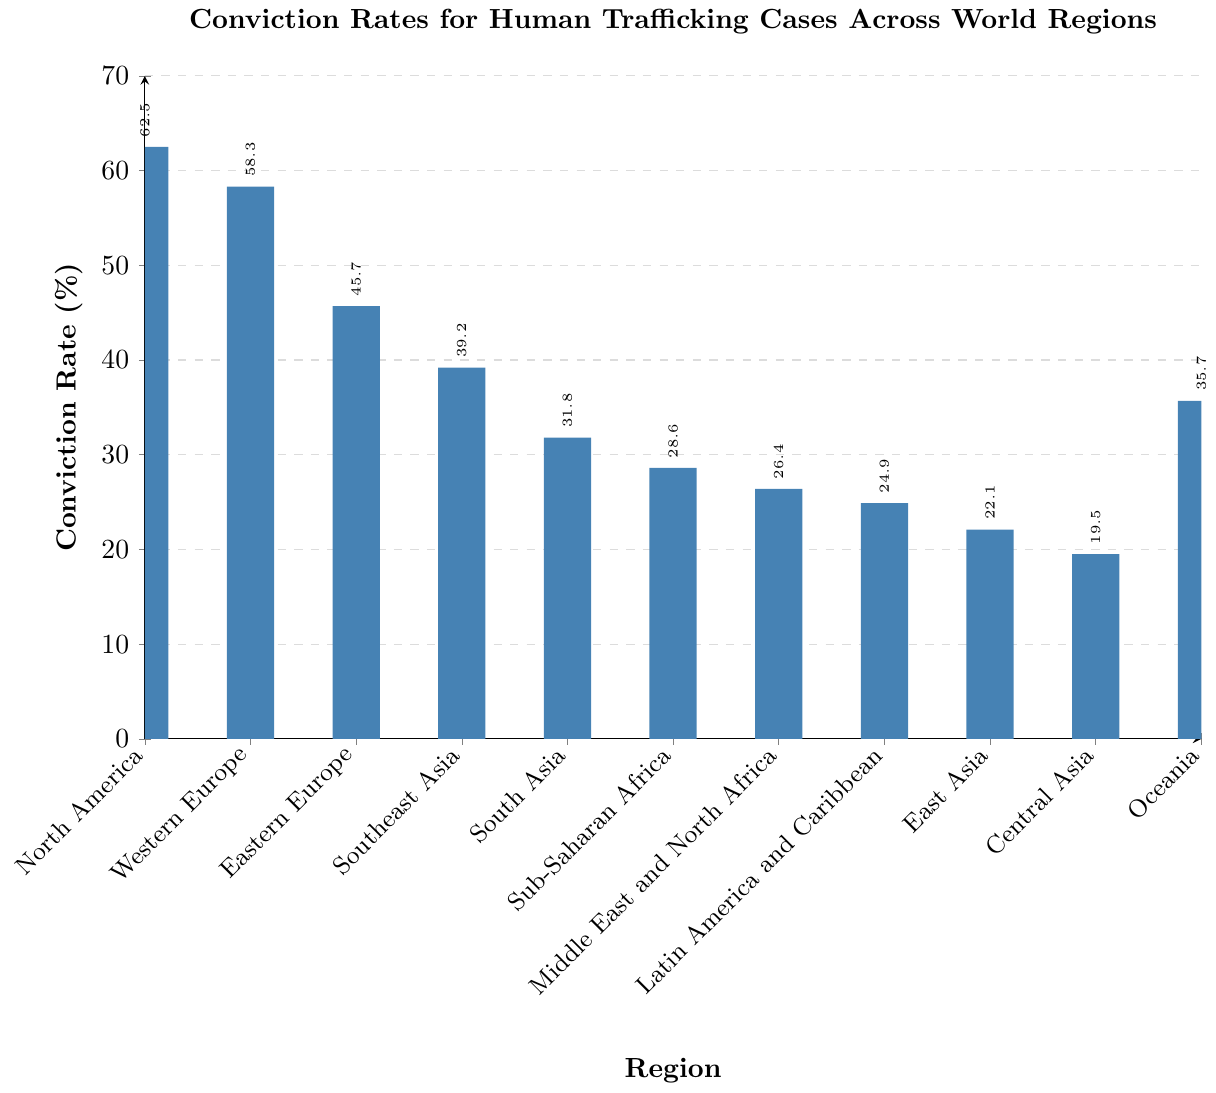Which region has the highest conviction rate for human trafficking cases? The region with the highest bar in the chart represents the highest conviction rate. The tallest bar corresponds to North America.
Answer: North America How much higher is the conviction rate in North America compared to East Asia? Find the conviction rates for North America (62.5%) and East Asia (22.1%) in the chart. Subtract the conviction rate of East Asia from that of North America (62.5% - 22.1% = 40.4%).
Answer: 40.4% Which regions have conviction rates below 30%? Identify the bars that are shorter than the 30% mark. The regions are Sub-Saharan Africa (28.6%), Middle East and North Africa (26.4%), Latin America and Caribbean (24.9%), East Asia (22.1%), and Central Asia (19.5%).
Answer: Sub-Saharan Africa, Middle East and North Africa, Latin America and Caribbean, East Asia, Central Asia What is the average conviction rate of Western Europe and Oceania? Add the conviction rates of Western Europe (58.3%) and Oceania (35.7%), then divide by 2: (58.3% + 35.7%) / 2 = 47%.
Answer: 47% Which regions have conviction rates closest to the overall median? Find the median value in the ordered list: [62.5, 58.3, 45.7, 39.2, 35.7, 31.8, 28.6, 26.4, 24.9, 22.1, 19.5]. The median is the 6th value (31.8% for South Asia). The regions closest to 31.8% are Southeast Asia (39.2%) and Sub-Saharan Africa (28.6%).
Answer: Southeast Asia, Sub-Saharan Africa What is the total conviction rate sum for all regions combined? Sum all conviction rates: 62.5% + 58.3% + 45.7% + 39.2% + 31.8% + 28.6% + 26.4% + 24.9% + 22.1% + 19.5% + 35.7% = 394.7%.
Answer: 394.7% Compare the conviction rate in Southeast Asia to South Asia. Which region has a higher conviction rate and by how much? Determine the conviction rates: Southeast Asia (39.2%) and South Asia (31.8%). Southeast Asia has a higher rate. Subtract the two rates: 39.2% - 31.8% = 7.4%.
Answer: Southeast Asia, 7.4% Is the conviction rate of Eastern Europe above or below 50%? Identify the conviction rate for Eastern Europe: 45.7%, which is below 50%.
Answer: Below 50% List the regions with conviction rates between 20% and 40%. Identify bars between the 20% and 40% marks: Southeast Asia (39.2%), South Asia (31.8%), Sub-Saharan Africa (28.6%), Middle East and North Africa (26.4%), and Latin America and Caribbean (24.9%).
Answer: Southeast Asia, South Asia, Sub-Saharan Africa, Middle East and North Africa, Latin America and Caribbean 